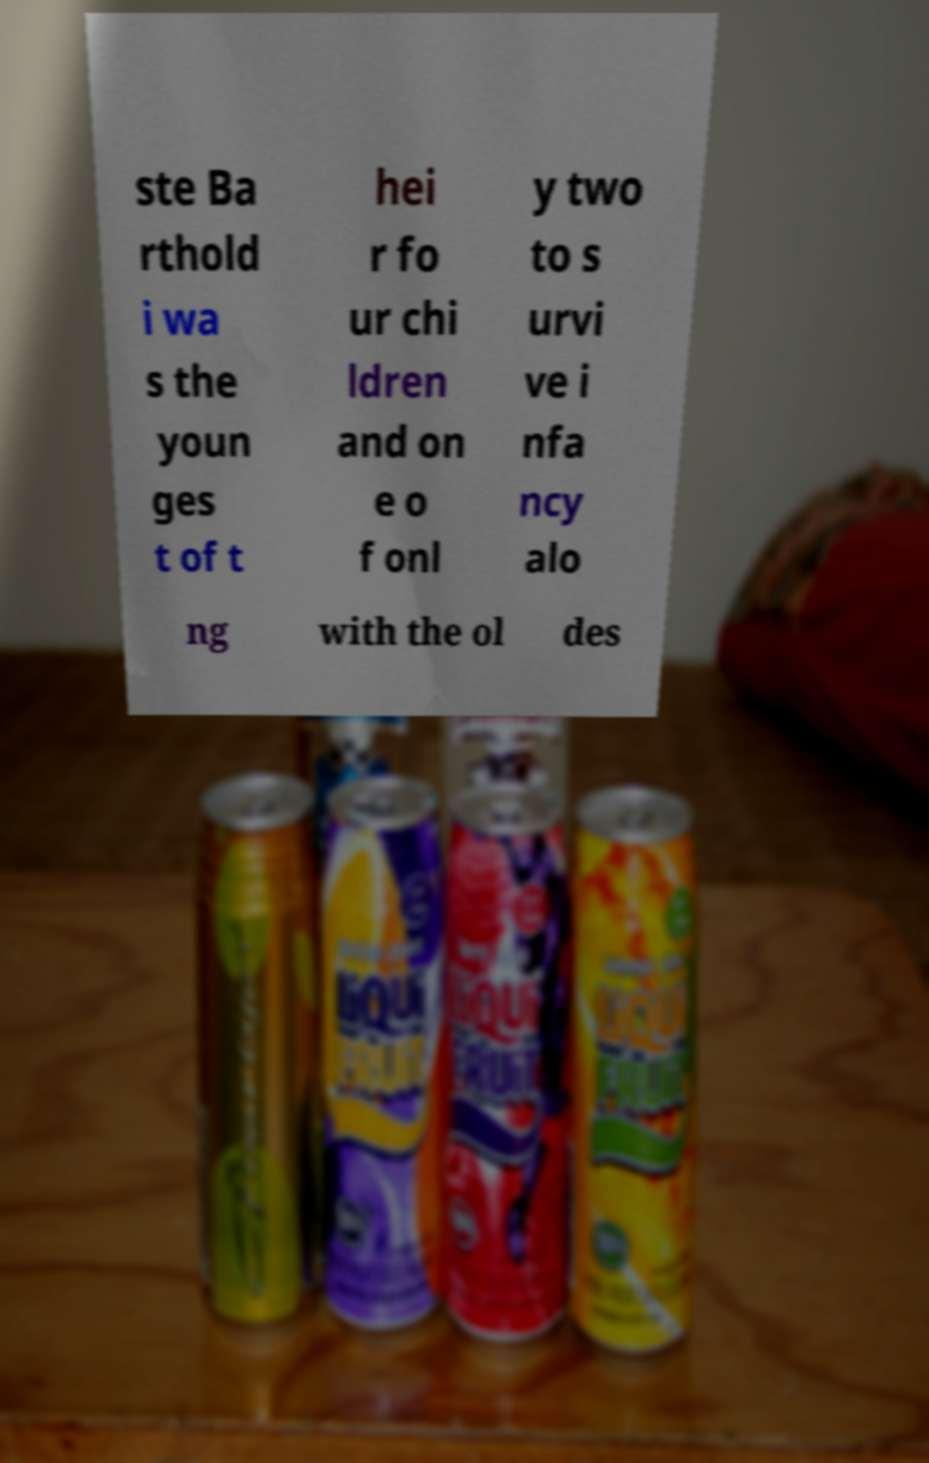Could you assist in decoding the text presented in this image and type it out clearly? ste Ba rthold i wa s the youn ges t of t hei r fo ur chi ldren and on e o f onl y two to s urvi ve i nfa ncy alo ng with the ol des 